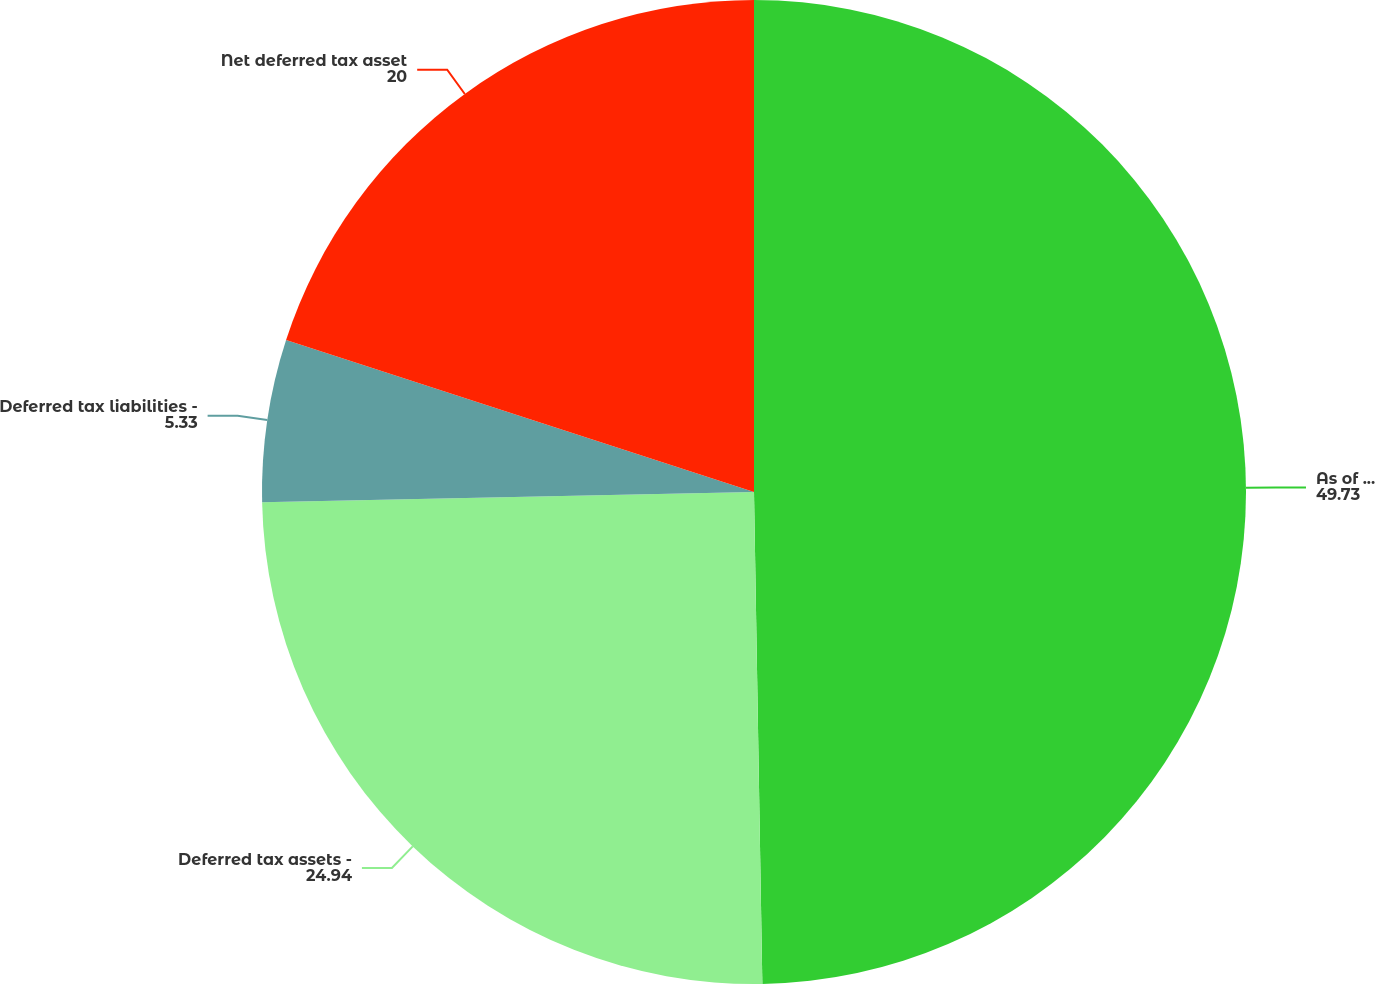<chart> <loc_0><loc_0><loc_500><loc_500><pie_chart><fcel>As of December 31<fcel>Deferred tax assets -<fcel>Deferred tax liabilities -<fcel>Net deferred tax asset<nl><fcel>49.73%<fcel>24.94%<fcel>5.33%<fcel>20.0%<nl></chart> 